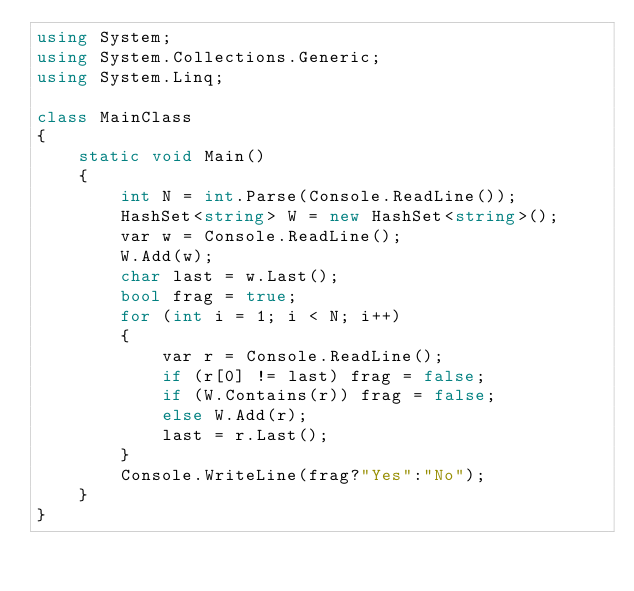<code> <loc_0><loc_0><loc_500><loc_500><_C#_>using System;
using System.Collections.Generic;
using System.Linq;

class MainClass
{
    static void Main()
    {
        int N = int.Parse(Console.ReadLine());
        HashSet<string> W = new HashSet<string>();
        var w = Console.ReadLine();
        W.Add(w);
        char last = w.Last();
        bool frag = true;
        for (int i = 1; i < N; i++)
        {
            var r = Console.ReadLine();
            if (r[0] != last) frag = false;
            if (W.Contains(r)) frag = false;
            else W.Add(r);
            last = r.Last();
        }
        Console.WriteLine(frag?"Yes":"No");
    }
}</code> 